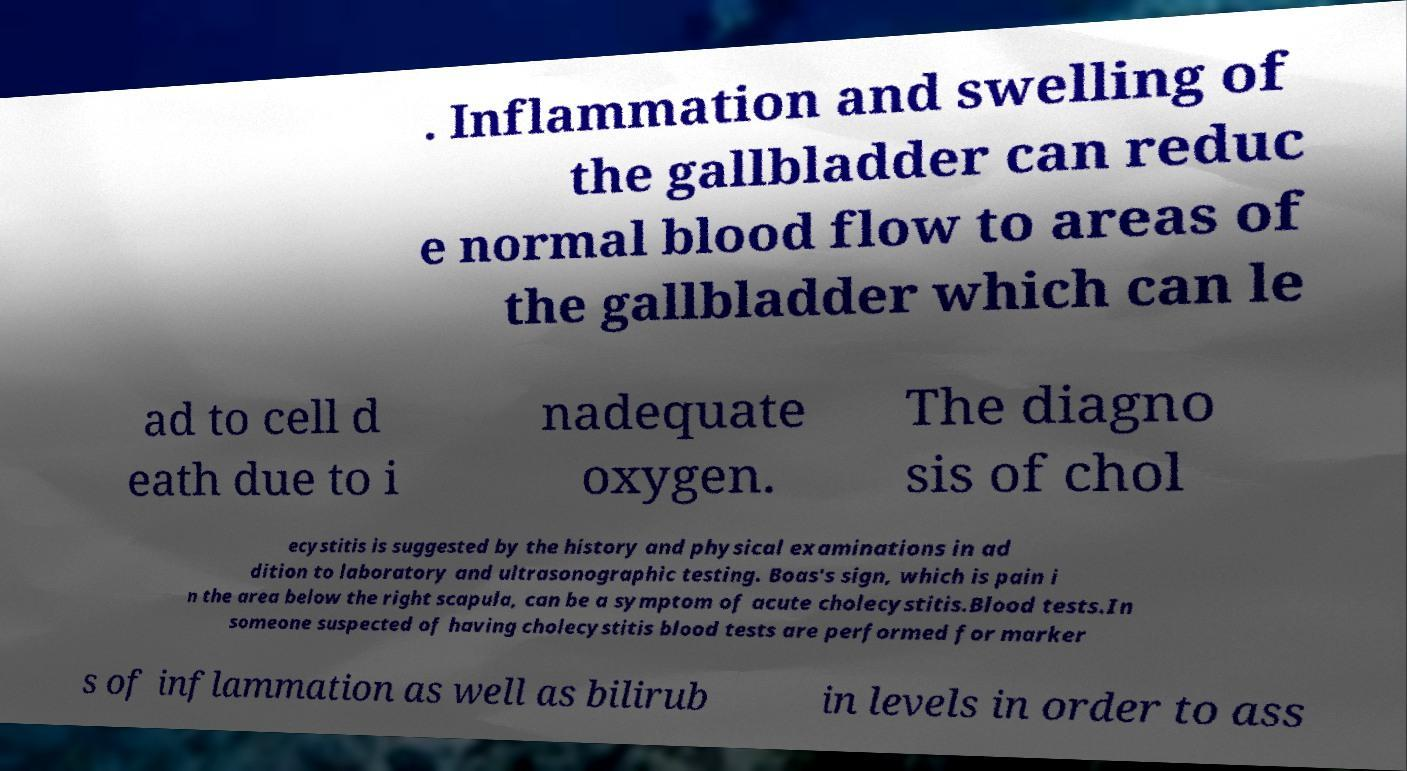Please identify and transcribe the text found in this image. . Inflammation and swelling of the gallbladder can reduc e normal blood flow to areas of the gallbladder which can le ad to cell d eath due to i nadequate oxygen. The diagno sis of chol ecystitis is suggested by the history and physical examinations in ad dition to laboratory and ultrasonographic testing. Boas's sign, which is pain i n the area below the right scapula, can be a symptom of acute cholecystitis.Blood tests.In someone suspected of having cholecystitis blood tests are performed for marker s of inflammation as well as bilirub in levels in order to ass 